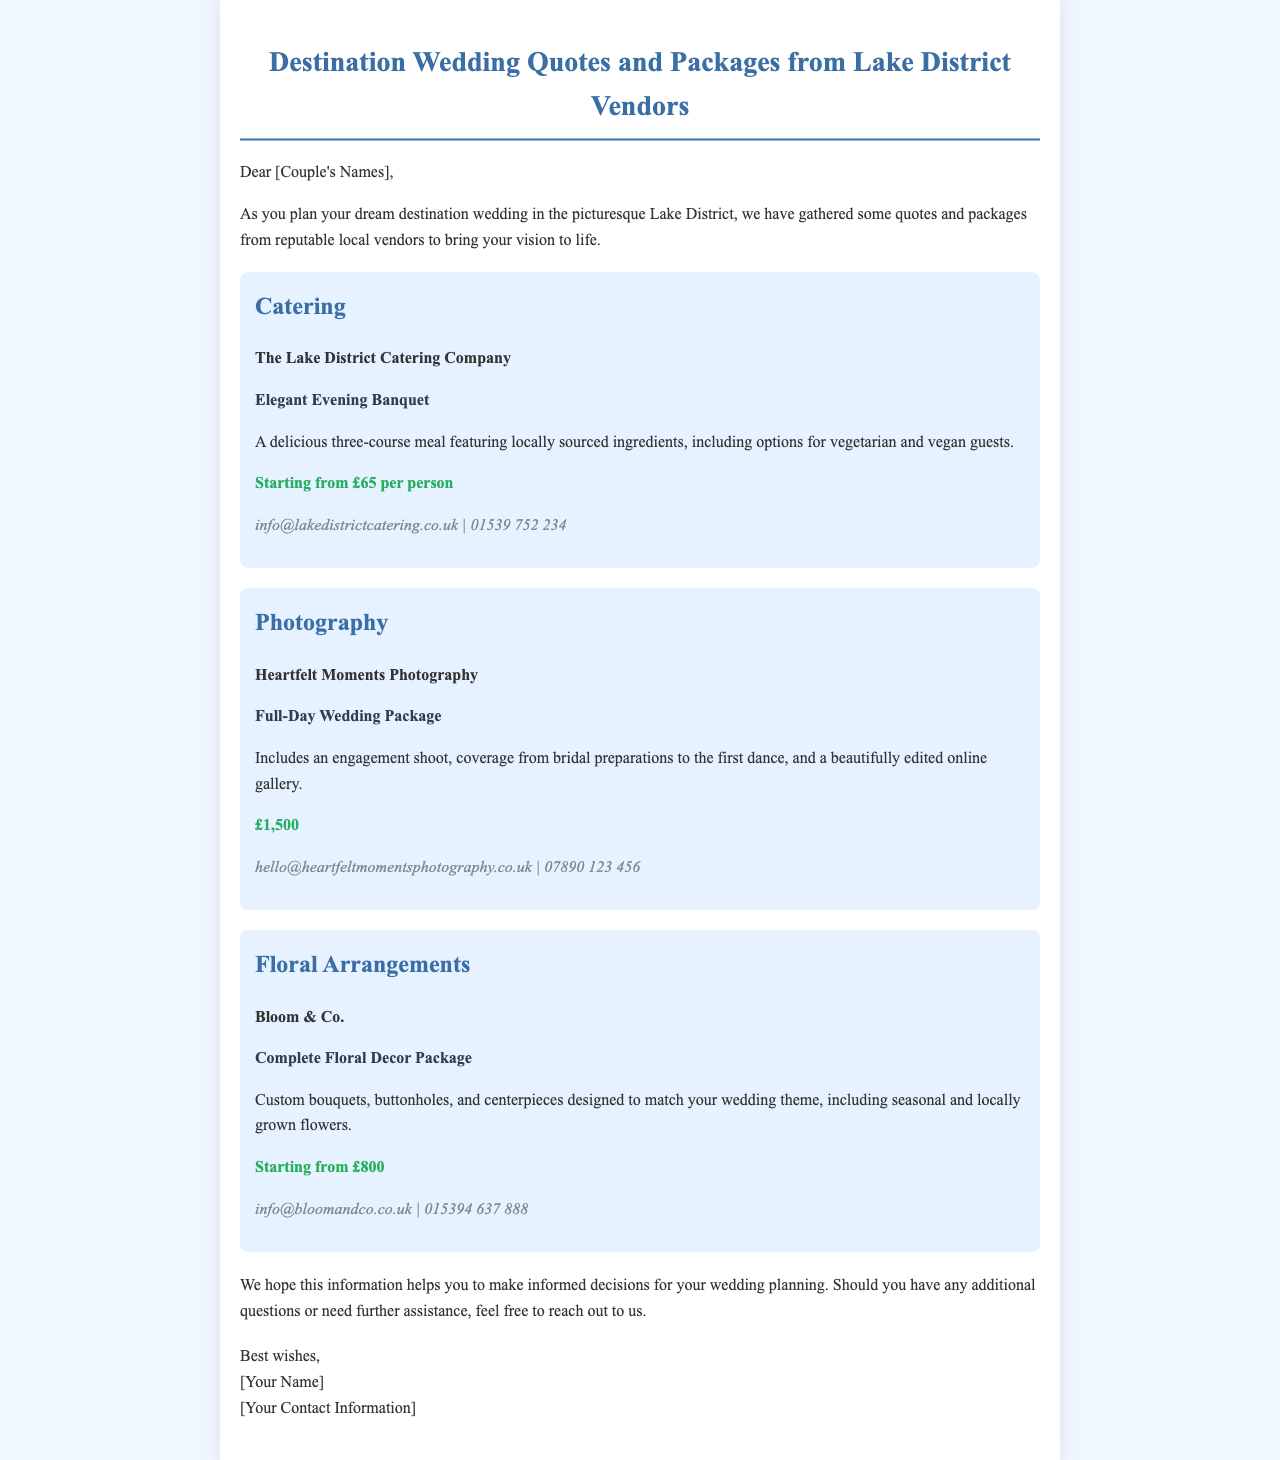What is the price for the Elegant Evening Banquet? The price for the Elegant Evening Banquet is stated as starting from £65 per person.
Answer: £65 per person Who provides the Full-Day Wedding Package? The vendor for the Full-Day Wedding Package is mentioned in the photography section, which is Heartfelt Moments Photography.
Answer: Heartfelt Moments Photography What does the Complete Floral Decor Package include? The Complete Floral Decor Package includes custom bouquets, buttonholes, and centerpieces designed to match your wedding theme.
Answer: Custom bouquets, buttonholes, and centerpieces What is the contact email for The Lake District Catering Company? The email provided for The Lake District Catering Company is located in the contact information section.
Answer: info@lakedistrictcatering.co.uk How much is the photography package? The price for the Full-Day Wedding Package is mentioned directly in the photography section of the document.
Answer: £1,500 What type of meal is included in the catering package? The type of meal included in the catering package is detailed as a three-course meal featuring locally sourced ingredients.
Answer: Three-course meal What is the significance of the phrase "starting from"? The phrase "starting from" indicates that the stated prices may vary and are the minimum cost for the services offered.
Answer: Minimum cost What genre of document is this? The genre of this document is a package quote summary for wedding planning as it outlines various vendors and their services.
Answer: Package quote summary 